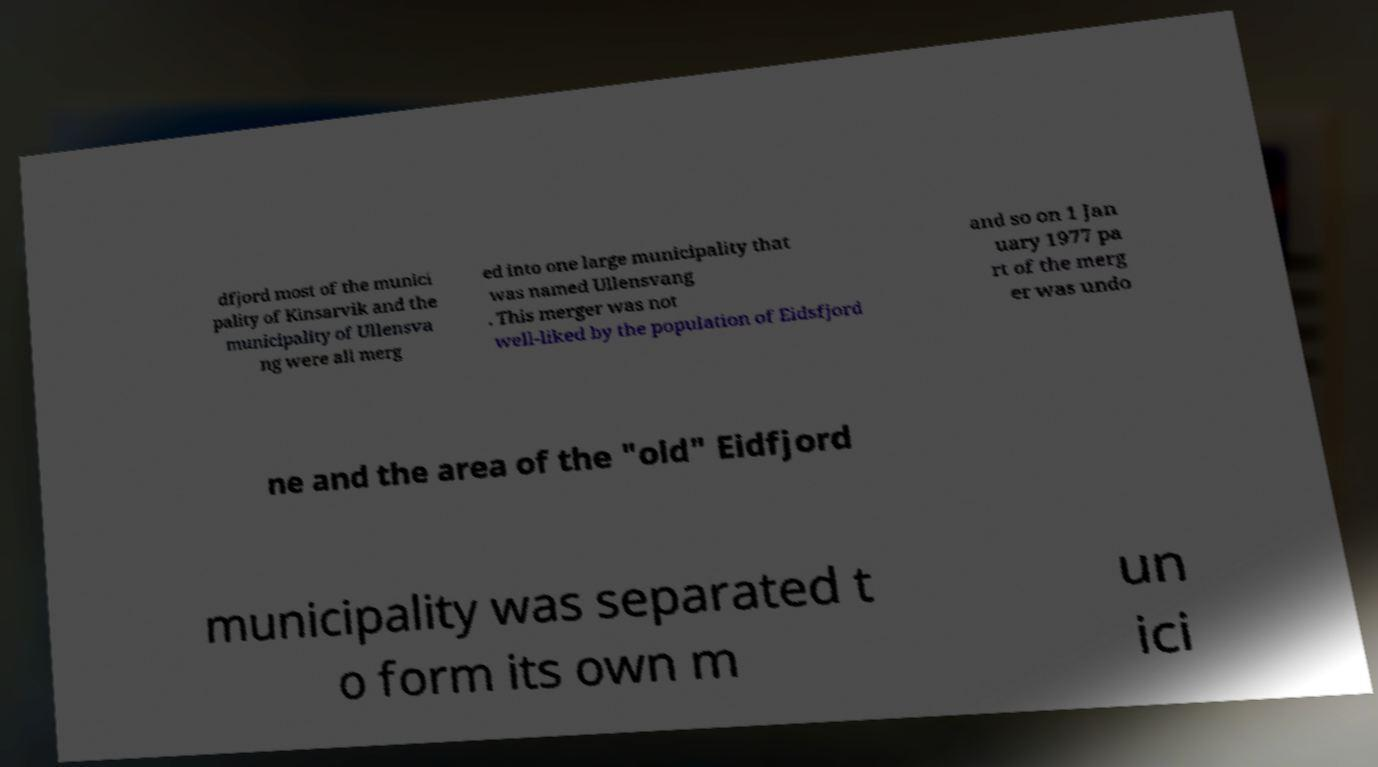Could you extract and type out the text from this image? dfjord most of the munici pality of Kinsarvik and the municipality of Ullensva ng were all merg ed into one large municipality that was named Ullensvang . This merger was not well-liked by the population of Eidsfjord and so on 1 Jan uary 1977 pa rt of the merg er was undo ne and the area of the "old" Eidfjord municipality was separated t o form its own m un ici 